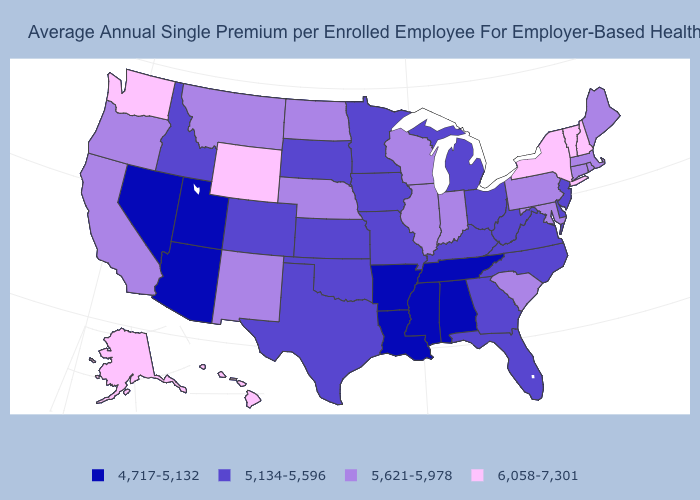What is the value of New Hampshire?
Answer briefly. 6,058-7,301. Which states have the highest value in the USA?
Keep it brief. Alaska, Hawaii, New Hampshire, New York, Vermont, Washington, Wyoming. What is the value of Idaho?
Give a very brief answer. 5,134-5,596. Does New York have the highest value in the USA?
Keep it brief. Yes. Which states have the lowest value in the USA?
Concise answer only. Alabama, Arizona, Arkansas, Louisiana, Mississippi, Nevada, Tennessee, Utah. What is the highest value in the MidWest ?
Give a very brief answer. 5,621-5,978. Among the states that border Illinois , does Missouri have the highest value?
Write a very short answer. No. Does Maine have the highest value in the Northeast?
Give a very brief answer. No. Does North Carolina have a higher value than Texas?
Keep it brief. No. Name the states that have a value in the range 5,134-5,596?
Concise answer only. Colorado, Delaware, Florida, Georgia, Idaho, Iowa, Kansas, Kentucky, Michigan, Minnesota, Missouri, New Jersey, North Carolina, Ohio, Oklahoma, South Dakota, Texas, Virginia, West Virginia. Name the states that have a value in the range 5,134-5,596?
Concise answer only. Colorado, Delaware, Florida, Georgia, Idaho, Iowa, Kansas, Kentucky, Michigan, Minnesota, Missouri, New Jersey, North Carolina, Ohio, Oklahoma, South Dakota, Texas, Virginia, West Virginia. What is the lowest value in the USA?
Give a very brief answer. 4,717-5,132. Does Virginia have a lower value than Indiana?
Give a very brief answer. Yes. Among the states that border South Dakota , does Wyoming have the highest value?
Be succinct. Yes. Does New Jersey have the lowest value in the Northeast?
Keep it brief. Yes. 